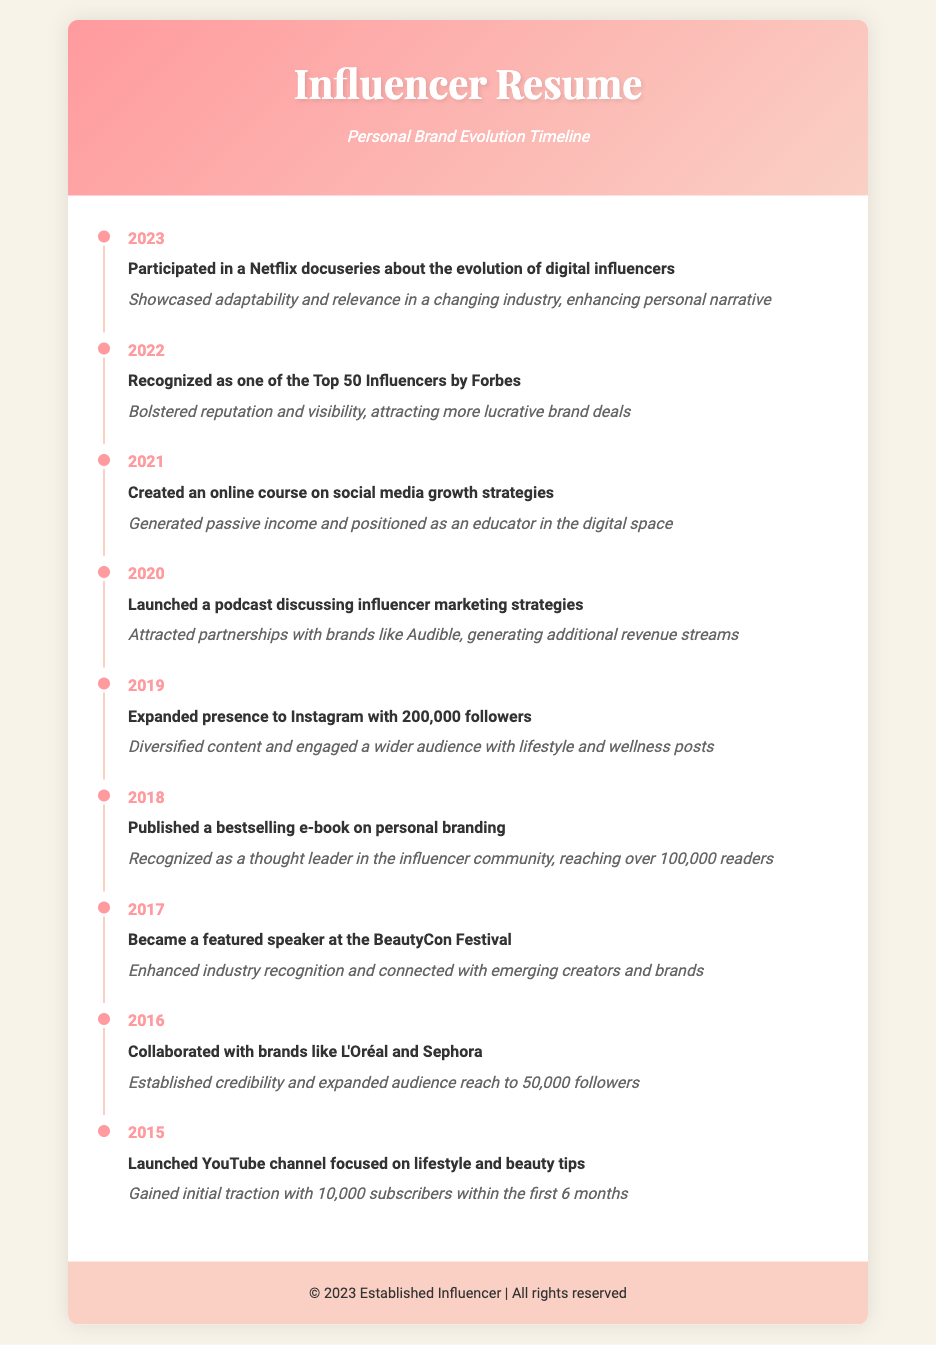What year did the influencer participate in a Netflix docuseries? The year mentioned for the participation in the Netflix docuseries is 2023.
Answer: 2023 What was recognized by Forbes in 2022? The document states that the influencer was recognized as one of the Top 50 Influencers by Forbes in 2022.
Answer: Top 50 Influencers How many followers did the influencer have on Instagram by 2019? The document indicates that the influencer expanded their presence to Instagram with 200,000 followers in 2019.
Answer: 200,000 followers Which milestone highlights the influencer's transition into educational content creation? The creation of an online course on social media growth strategies in 2021 demonstrates this transition.
Answer: Online course In which year did the influencer launch their YouTube channel? The document specifies that the YouTube channel was launched in 2015.
Answer: 2015 What type of content was focused on in the influencer's podcast launched in 2020? The podcast discussed influencer marketing strategies.
Answer: Influencer marketing strategies Which brands did the influencer collaborate with in 2016? The collaborations mentioned are with brands like L'Oréal and Sephora.
Answer: L'Oréal and Sephora What impact did publishing a bestselling e-book have on the influencer's status? It recognized them as a thought leader in the influencer community.
Answer: Thought leader Which event featured the influencer as a speaker in 2017? The document mentions the BeautyCon Festival as the event where the influencer was a featured speaker.
Answer: BeautyCon Festival 